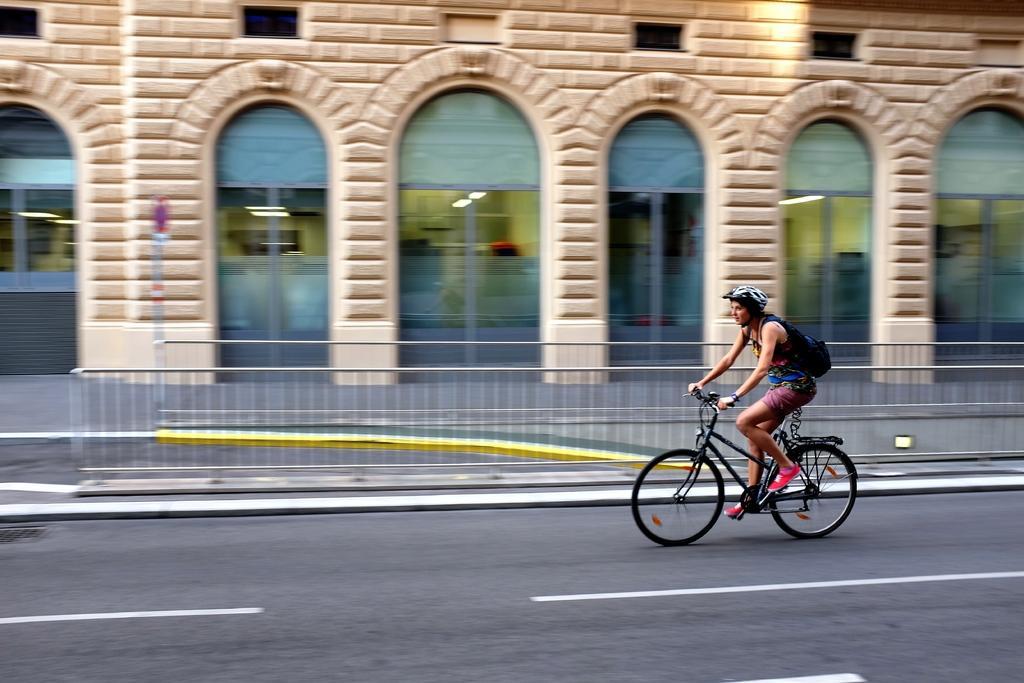How would you summarize this image in a sentence or two? In this picture there is a woman wearing a backpack and helmet is riding a bicycle on the road. There is a building and a light in the building. 